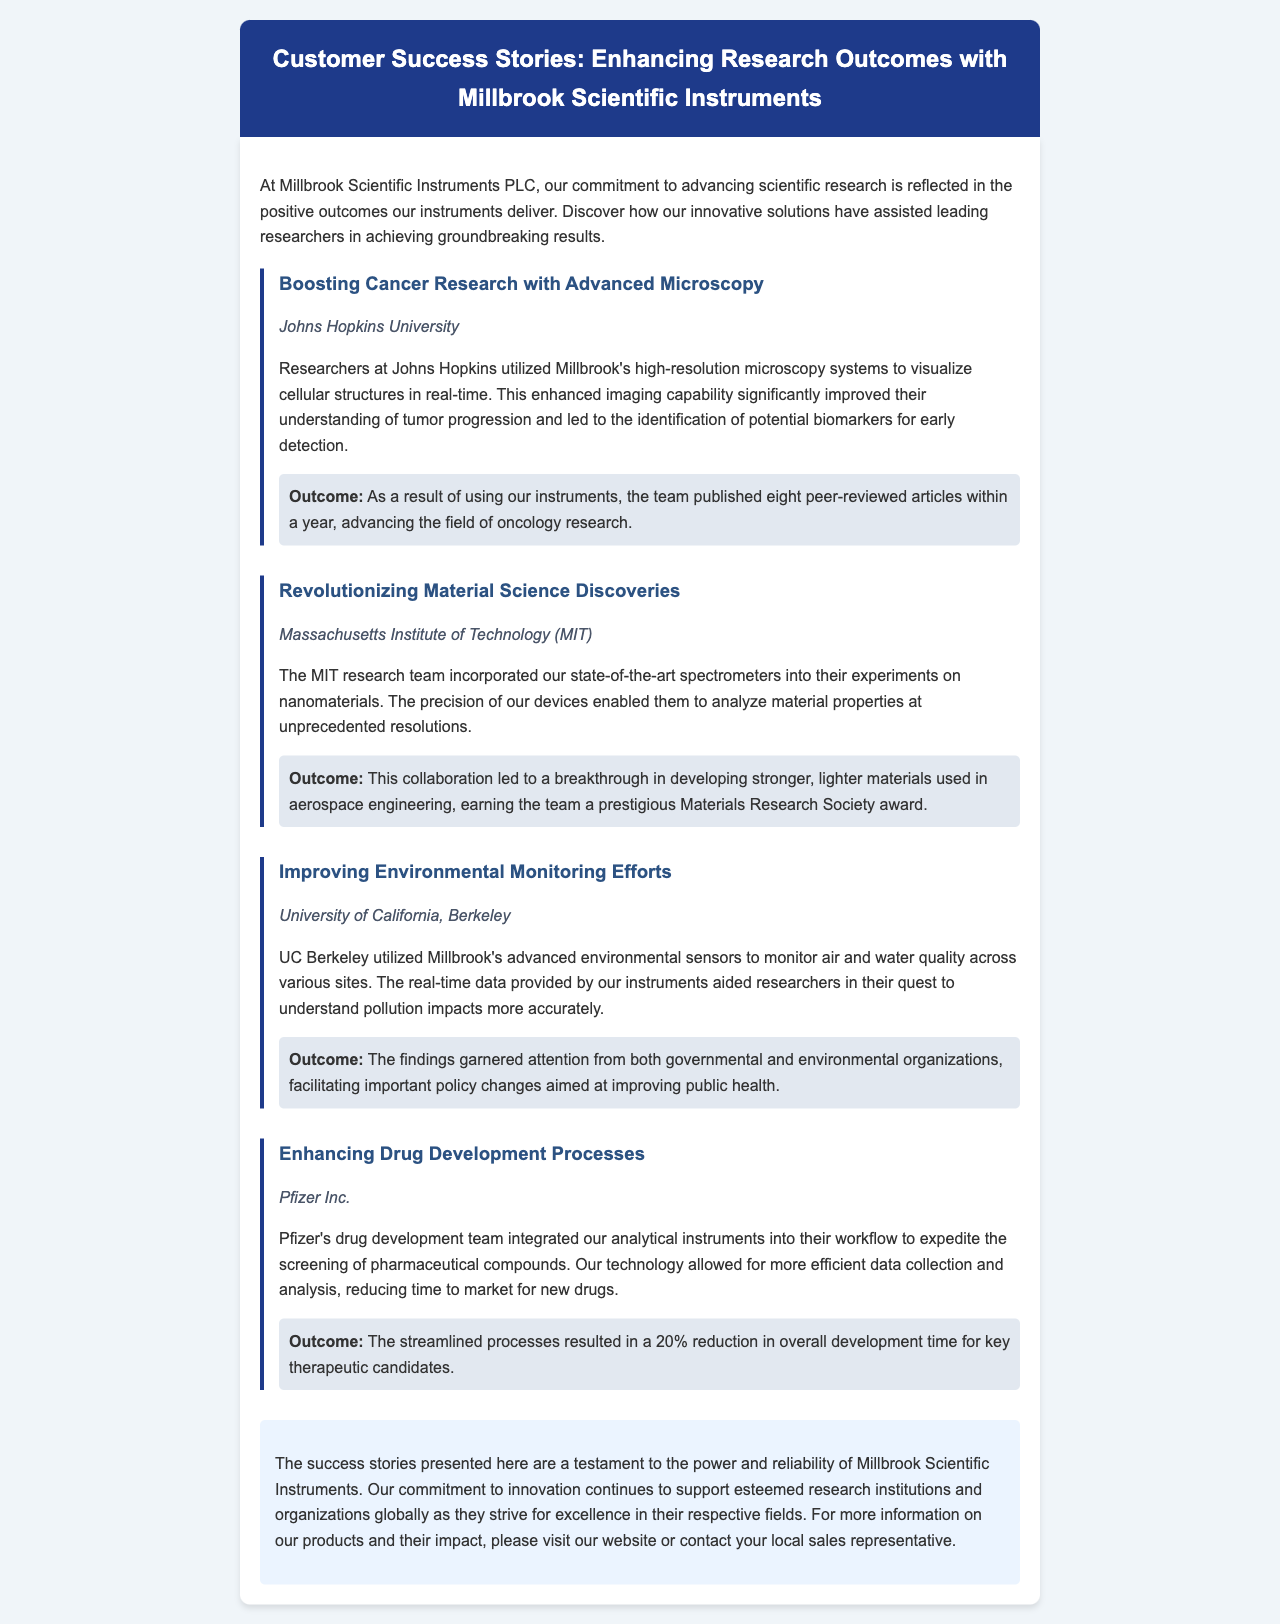What institution utilized high-resolution microscopy systems? The document states that researchers at Johns Hopkins University utilized the microscopy systems.
Answer: Johns Hopkins University How many peer-reviewed articles did the team at Johns Hopkins publish? The article notes that the team published eight peer-reviewed articles within a year.
Answer: eight What technology did MIT use for their nanomaterials experiments? The document mentions that MIT incorporated state-of-the-art spectrometers into their experiments.
Answer: spectrometers What award did the MIT team earn due to their research? The success story indicates that the team earned a prestigious Materials Research Society award.
Answer: Materials Research Society award Which company integrated analytical instruments into their drug development workflow? According to the article, Pfizer Inc. integrated analytical instruments into their workflow.
Answer: Pfizer Inc What was the percentage reduction in development time for key therapeutic candidates at Pfizer? The document states that there was a 20% reduction in overall development time.
Answer: 20% Which institution improved air and water quality monitoring with advanced sensors? The success story indicates that the University of California, Berkeley utilized advanced environmental sensors.
Answer: University of California, Berkeley What type of issues did the findings from UC Berkeley facilitate policy changes in? The document highlights that the findings facilitated important policy changes aimed at improving public health.
Answer: public health 